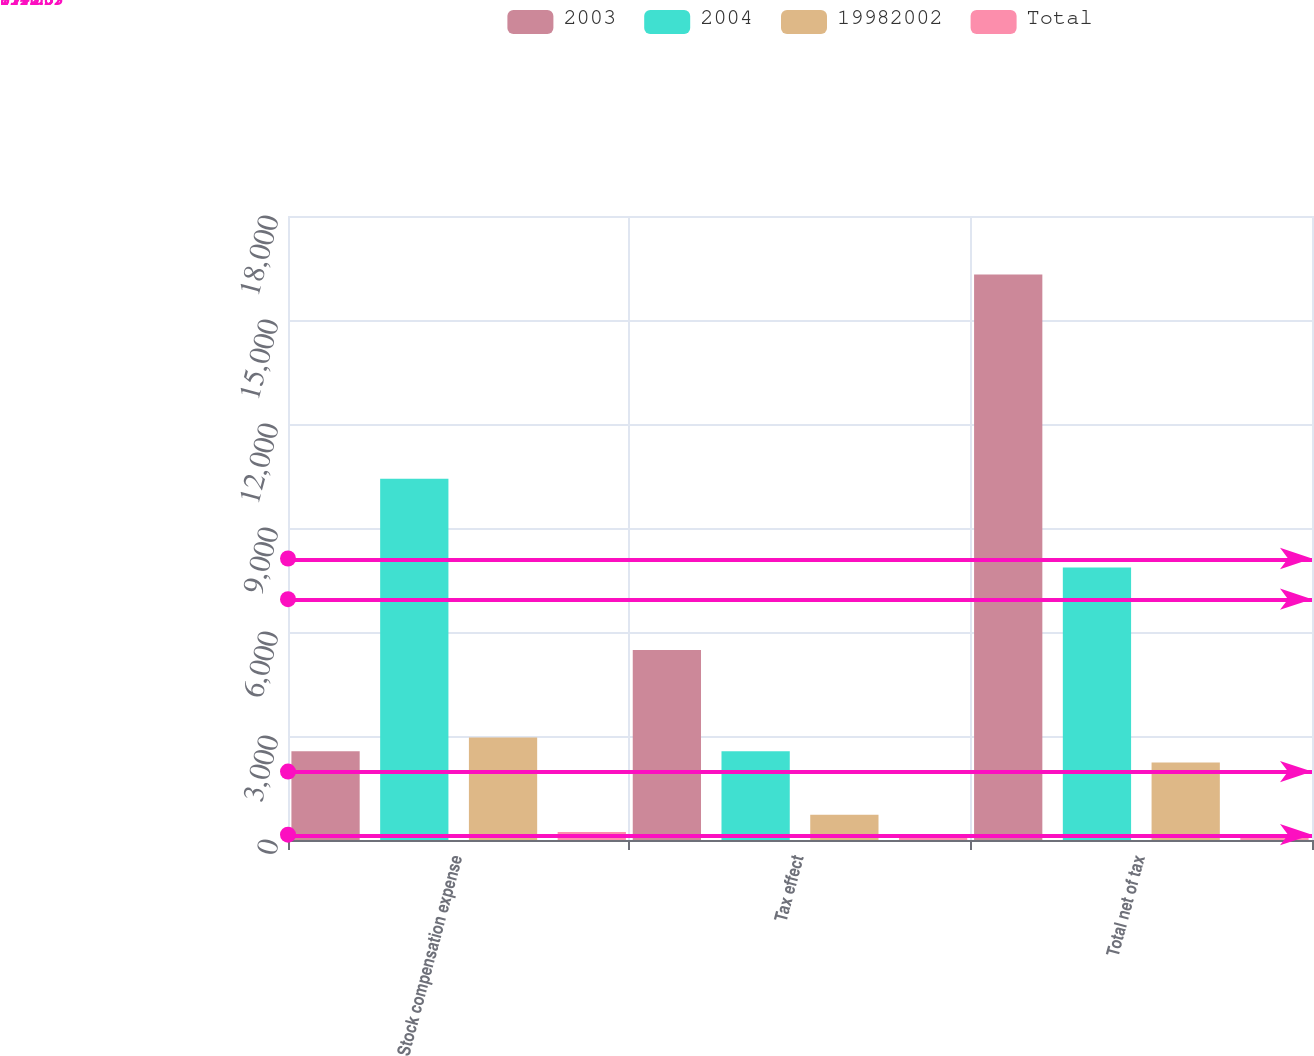Convert chart to OTSL. <chart><loc_0><loc_0><loc_500><loc_500><stacked_bar_chart><ecel><fcel>Stock compensation expense<fcel>Tax effect<fcel>Total net of tax<nl><fcel>2003<fcel>2558<fcel>5484<fcel>16316<nl><fcel>2004<fcel>10420<fcel>2558<fcel>7862<nl><fcel>19982002<fcel>2959<fcel>726<fcel>2233<nl><fcel>Total<fcel>230<fcel>57<fcel>173<nl></chart> 